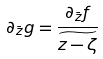Convert formula to latex. <formula><loc_0><loc_0><loc_500><loc_500>\partial _ { \bar { z } } g = \frac { \partial _ { \bar { z } } f } { \widetilde { z - \zeta } }</formula> 